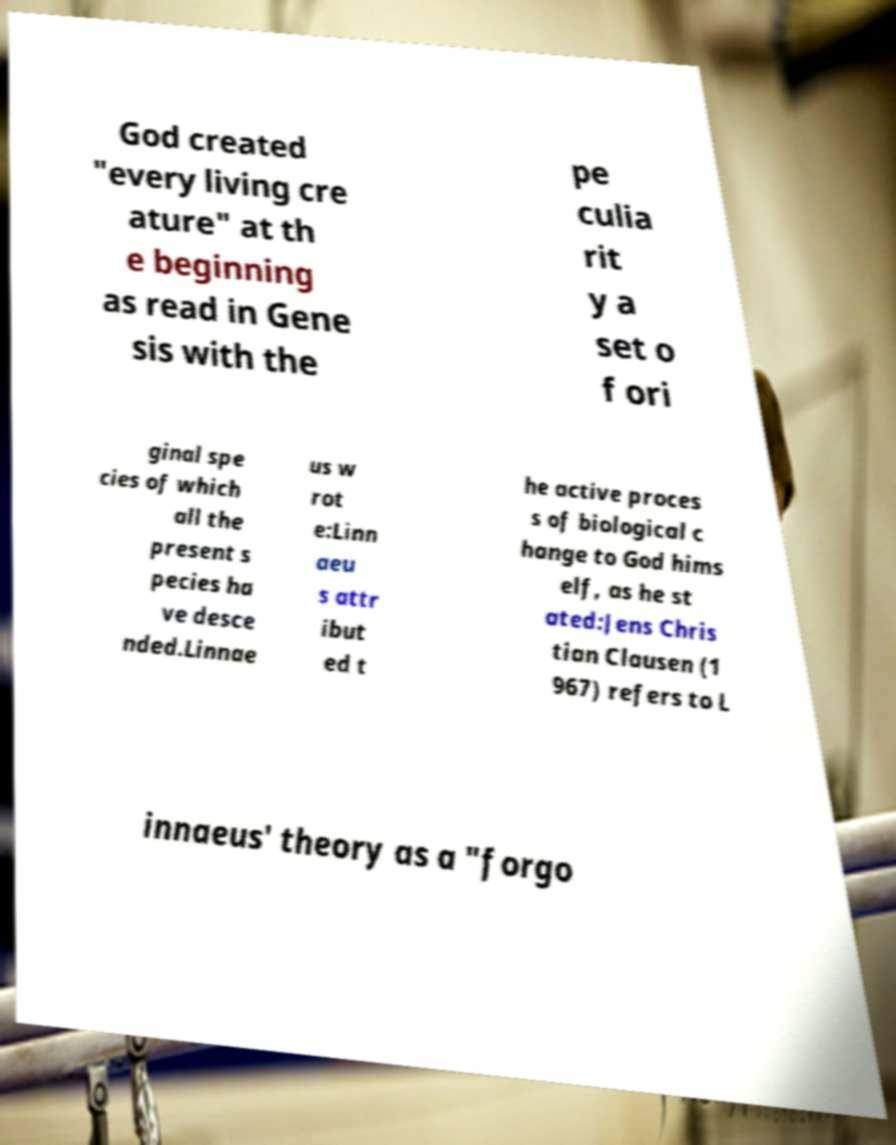For documentation purposes, I need the text within this image transcribed. Could you provide that? God created "every living cre ature" at th e beginning as read in Gene sis with the pe culia rit y a set o f ori ginal spe cies of which all the present s pecies ha ve desce nded.Linnae us w rot e:Linn aeu s attr ibut ed t he active proces s of biological c hange to God hims elf, as he st ated:Jens Chris tian Clausen (1 967) refers to L innaeus' theory as a "forgo 